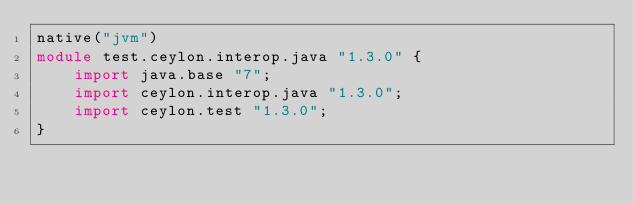Convert code to text. <code><loc_0><loc_0><loc_500><loc_500><_Ceylon_>native("jvm")
module test.ceylon.interop.java "1.3.0" {
    import java.base "7";
    import ceylon.interop.java "1.3.0";
    import ceylon.test "1.3.0";
}
</code> 